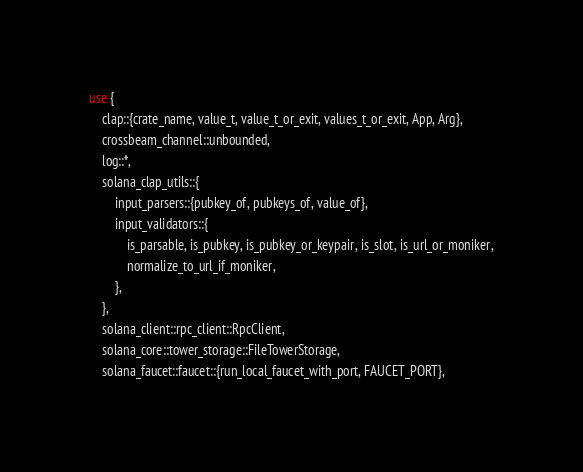<code> <loc_0><loc_0><loc_500><loc_500><_Rust_>use {
    clap::{crate_name, value_t, value_t_or_exit, values_t_or_exit, App, Arg},
    crossbeam_channel::unbounded,
    log::*,
    solana_clap_utils::{
        input_parsers::{pubkey_of, pubkeys_of, value_of},
        input_validators::{
            is_parsable, is_pubkey, is_pubkey_or_keypair, is_slot, is_url_or_moniker,
            normalize_to_url_if_moniker,
        },
    },
    solana_client::rpc_client::RpcClient,
    solana_core::tower_storage::FileTowerStorage,
    solana_faucet::faucet::{run_local_faucet_with_port, FAUCET_PORT},</code> 